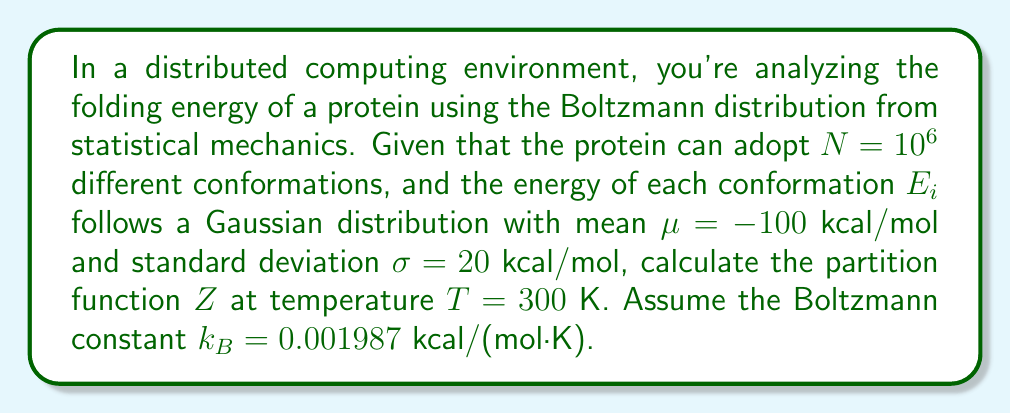Can you answer this question? To solve this problem, we'll follow these steps:

1) Recall the partition function formula:
   $$Z = \sum_{i=1}^N e^{-E_i/k_BT}$$

2) Given the large number of conformations and the Gaussian distribution of energies, we can approximate the sum with an integral:
   $$Z \approx N \int_{-\infty}^{\infty} e^{-E/k_BT} P(E) dE$$
   where $P(E)$ is the probability density function of the Gaussian distribution.

3) The Gaussian PDF is given by:
   $$P(E) = \frac{1}{\sigma\sqrt{2\pi}} e^{-\frac{(E-\mu)^2}{2\sigma^2}}$$

4) Substituting this into our integral:
   $$Z \approx N \int_{-\infty}^{\infty} e^{-E/k_BT} \cdot \frac{1}{\sigma\sqrt{2\pi}} e^{-\frac{(E-\mu)^2}{2\sigma^2}} dE$$

5) Simplify the exponent:
   $$Z \approx \frac{N}{\sigma\sqrt{2\pi}} \int_{-\infty}^{\infty} \exp\left(-\frac{E}{k_BT} - \frac{(E-\mu)^2}{2\sigma^2}\right) dE$$

6) Complete the square in the exponent:
   $$Z \approx \frac{N}{\sigma\sqrt{2\pi}} \exp\left(\frac{\mu}{k_BT} + \frac{\sigma^2}{2(k_BT)^2}\right) \int_{-\infty}^{\infty} \exp\left(-\frac{(E-(\mu-\sigma^2/k_BT))^2}{2\sigma^2}\right) dE$$

7) The integral evaluates to $\sigma\sqrt{2\pi}$, so:
   $$Z \approx N \exp\left(\frac{\mu}{k_BT} + \frac{\sigma^2}{2(k_BT)^2}\right)$$

8) Now, let's substitute the given values:
   $N = 10^6$
   $\mu = -100$ kcal/mol
   $\sigma = 20$ kcal/mol
   $T = 300$ K
   $k_B = 0.001987$ kcal/(mol·K)

9) Calculate:
   $$Z \approx 10^6 \exp\left(\frac{-100}{0.001987 \cdot 300} + \frac{20^2}{2(0.001987 \cdot 300)^2}\right)$$
   $$Z \approx 10^6 \exp(-167.59 + 280.17)$$
   $$Z \approx 10^6 \exp(112.58)$$
   $$Z \approx 10^6 \cdot 6.36 \times 10^{48}$$
   $$Z \approx 6.36 \times 10^{54}$$
Answer: $Z \approx 6.36 \times 10^{54}$ 